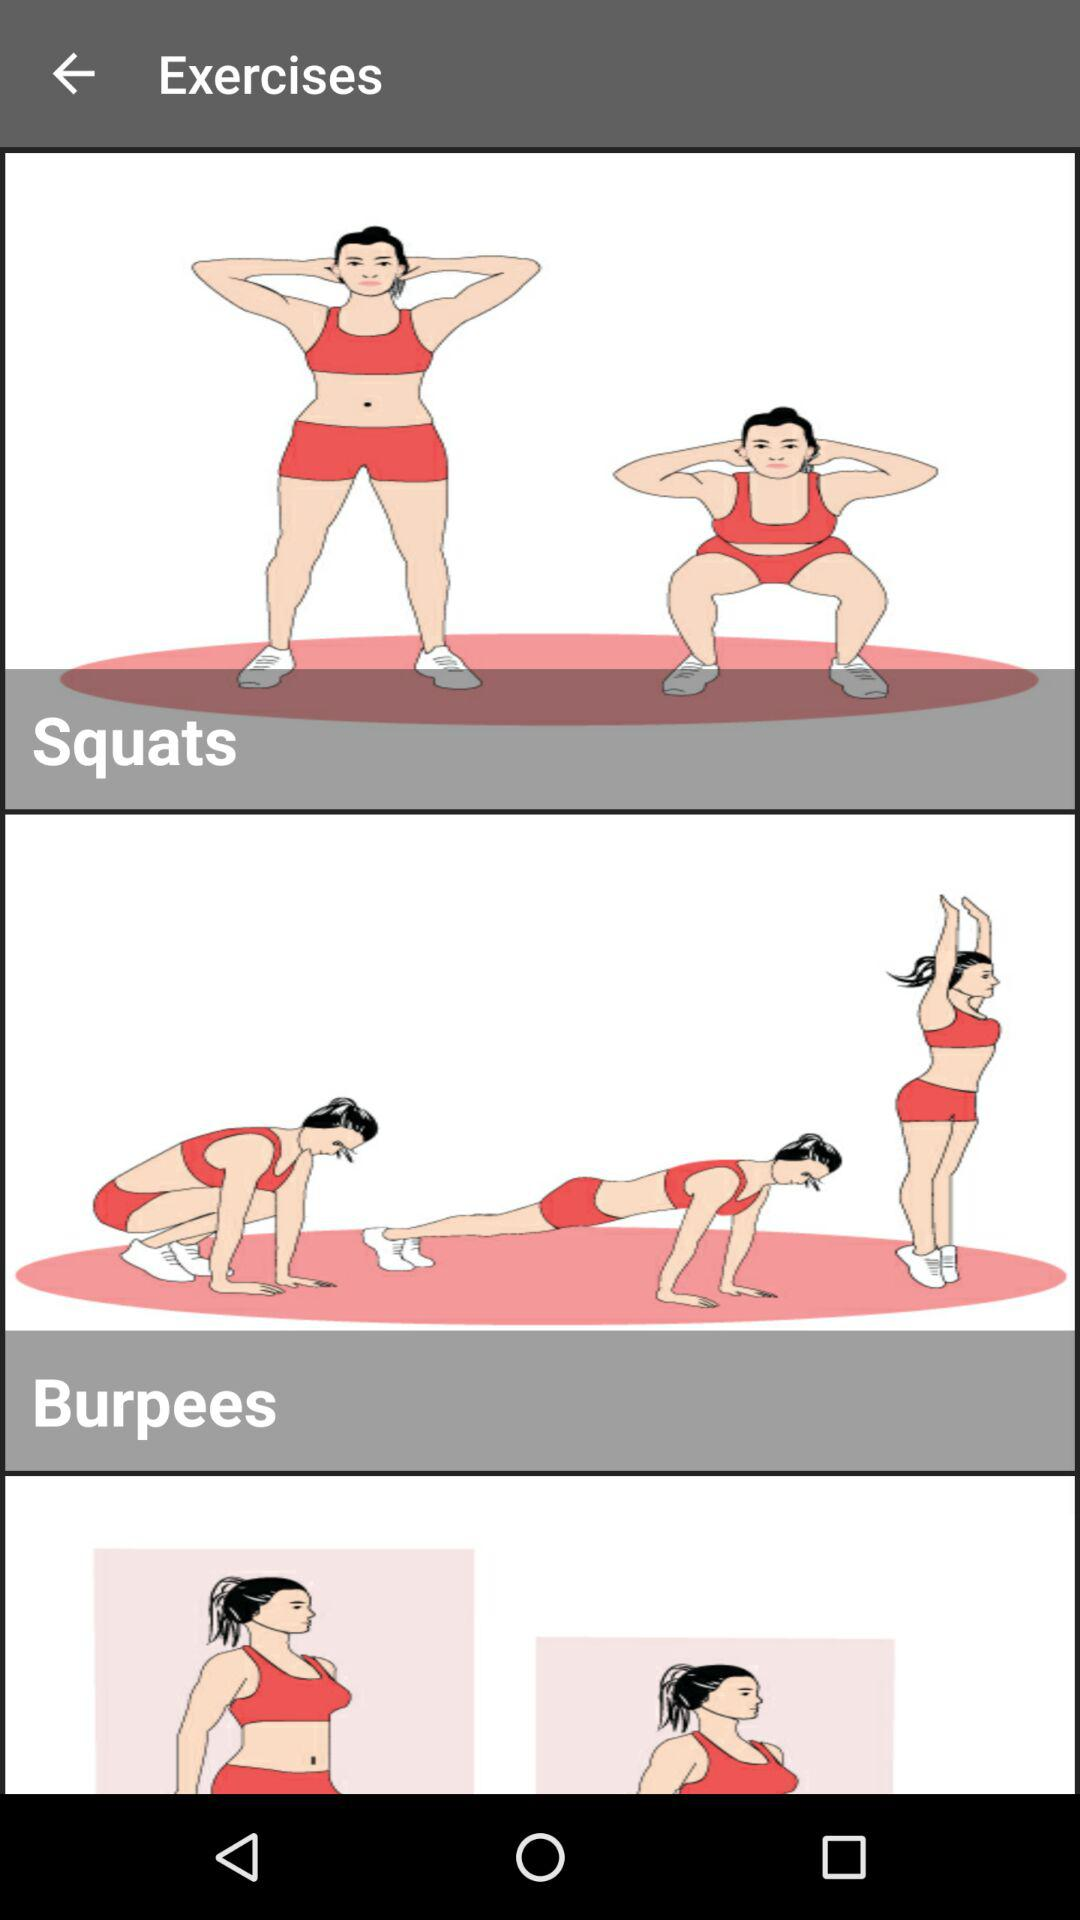How many calories does "Squats" burn?
When the provided information is insufficient, respond with <no answer>. <no answer> 